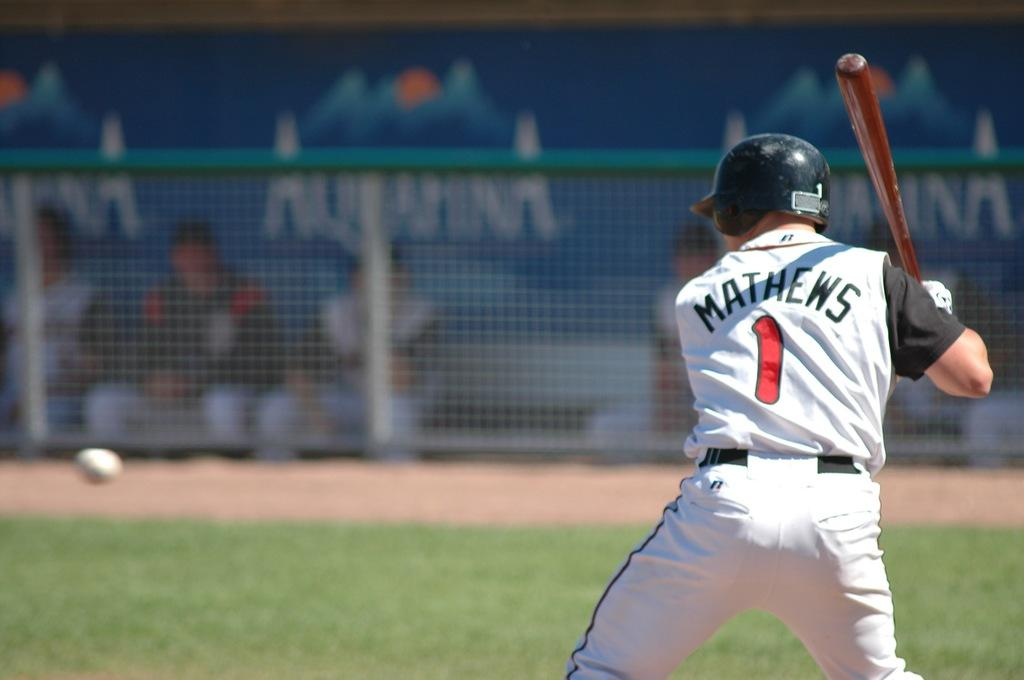Provide a one-sentence caption for the provided image. The batter Matthews is ready for the pitch and in the background other players watch against an Aquafina advertisement. 